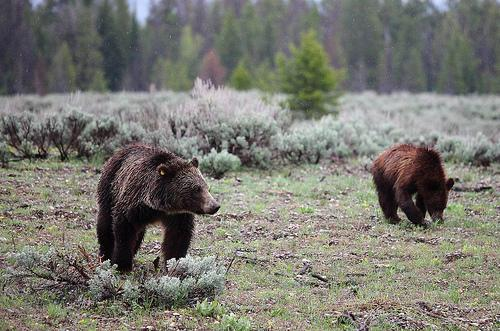What type of trees and shrubs can be seen in the image? There are small green and red trees, as well as green bushes and various small shrubs on the ground. How many bears are present in the image and what kind of terrain are they in? There are two bears present, and they are in a meadow with woods behind it. Could you provide a brief description of the objects found in the background? In the background, there are woods, a small green tree, a small red tree, and green trees in the distance. Examine the image for object count and provide the number of bears, trees, and shrubs. There are 2 bears, 3 trees (one green, one red, and one in the distance), and 9 small shrubs. What kind of reasoning or deductions can you make about the bears in this image? The bears seem to be exploring their surroundings in a peaceful manner, possibly searching for food or just enjoying the meadow environment. They may be content, as their body language does not suggest aggression or distress. What is the overall sentiment or mood of the image? The mood of the image is calm and peaceful, as the bears are gently exploring the meadow. Are there any animal interactions in this image? If yes, please describe. No direct animal interactions are present, but the bears may be somewhat aware of each other as they roam the meadow. Identify the main creatures present in the image and their activity. Two bears are roaming through a meadow, walking on all fours and sniffing the grass. List the different activities the bears are engaged in. The bears are roaming, walking on grass, sniffing the grass, facing away from the camera, and walking on a field. Enumerate the distinct features of the bears in the image. The bears have a brown color, eyes, nose, right ear, left ear, and are on all fours. Evaluate the quality of the image. The image is of high quality, with clear objects and well-defined details, such as the bear's eyes, nose, and ears. Read any text present in the image. There is no text present in the image. Segment the image into different semantic regions based on the given information. The image can be segmented into the following semantic regions: bears, meadow, small trees, wooded area, and grass/bushes on the ground. Describe the position of the small red tree in relation to the bears. The small red tree is behind the bears with coordinates (X:196 Y:46) and sizes (Width:32 Height:32). Is there any water in the image according to the provided information? No, there is no water mentioned in the image information. Is there a bear wearing glasses? No, it's not mentioned in the image. Describe the image based on the given information. The image shows two bears roaming in a meadow, with one brown bear facing away from the camera. There are small trees, green and red, behind the bears, and a wooded area in the distance. The bears are walking on all fours and sniffing the grass. There are also small shrubs and green bushes on the ground. One of the bears is a polar bear. Identify any anomalies in the image information. The polar bear is an anomaly, as it's not typically found with brown bears in a meadow environment. Identify any object attributes in the image. The bears have attributes like black and brown colors, one of them being a polar bear, and their eyes, nose, and ears are clearly visible. The trees have attributes like green and red colors, and they are small in size. How many bears are present in the picture, and can you determine their species? There are two bears in the picture, one brown bear and one polar bear. Answer the question based on the image information: Are there any polar bears in the image? Yes, there are polar bears in the image. Identify the main objects in the image along with their coordinates and sizes. There are two bears with coordinates (X:2 Y:3) and sizes (Width:494 Height:494), green and red trees behind the bears with coordinates (X:270 Y:29) and (X:196 Y:46), and sizes (Width:77 Height:77) and (Width:32 Height:32), respectively. There's also a wooded area with coordinates (X:2 Y:3) and sizes (Width:496 Height:496). Analyze the interaction between objects in the image. The bears are interacting with their environment by roaming in the meadow, sniffing the grass, and being surrounded by trees and bushes. Ground each expression to corresponding objects in the image. "two bears roaming through a meadow" refers to the bears at (X:2 Y:3), "a small green tree" refers to the tree at (X:270 Y:29), "the nose of the bear" refers to the bear's nose at (X:198 Y:194). Determine the sentiment conveyed by this image. The image conveys a calm and peaceful sentiment as it captures bears roaming through a meadow. Can you find a bear standing on two legs? There are several mentions of bears in the image, but they are all on all fours, walking or standing. No bear is described as standing on two legs. Give a brief description of the bears and their behavior in the image. The bears are walking on all fours, sniffing the grass, and roaming through a meadow. 